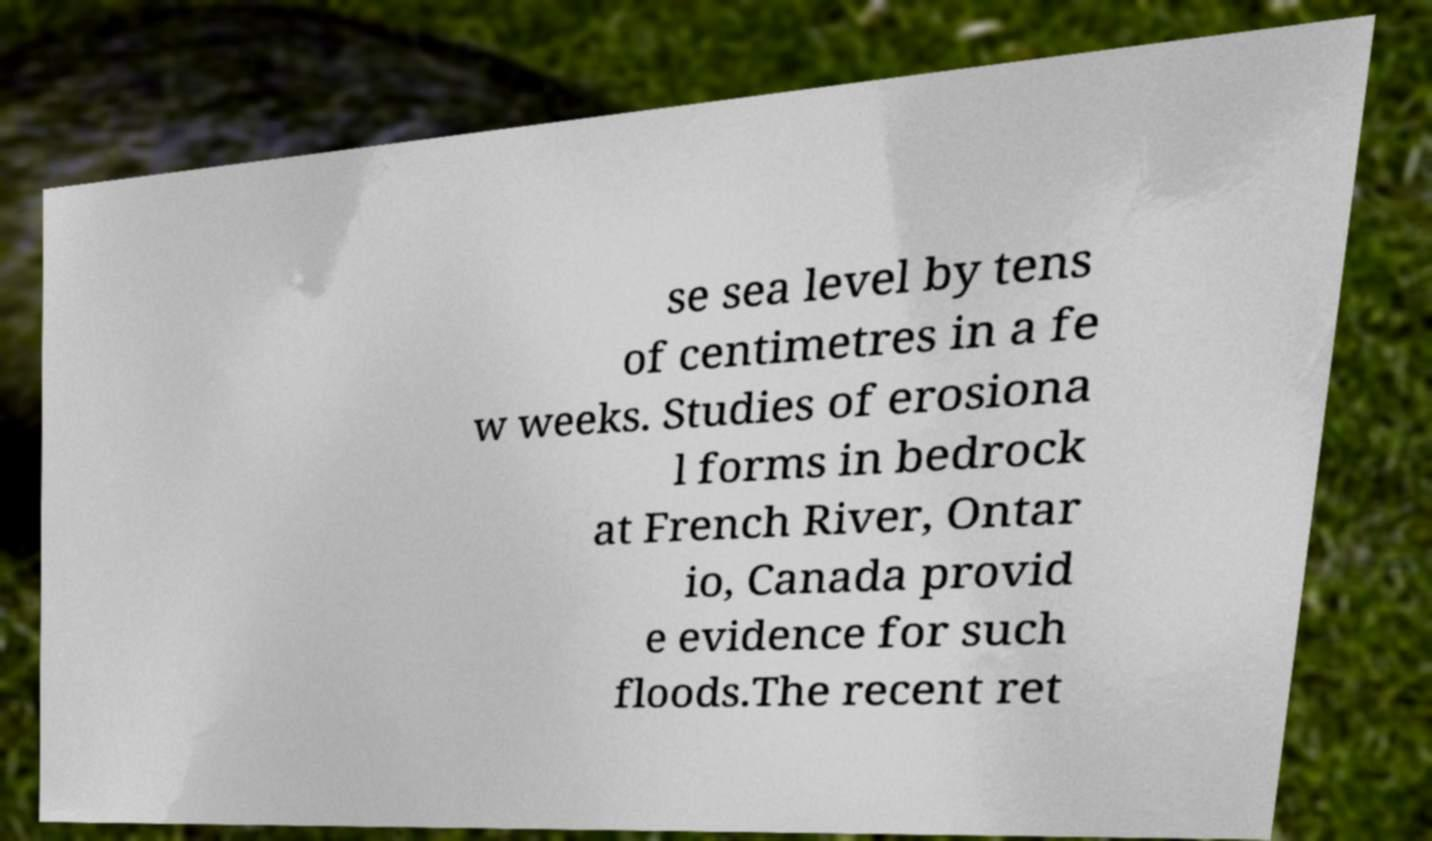Please identify and transcribe the text found in this image. se sea level by tens of centimetres in a fe w weeks. Studies of erosiona l forms in bedrock at French River, Ontar io, Canada provid e evidence for such floods.The recent ret 